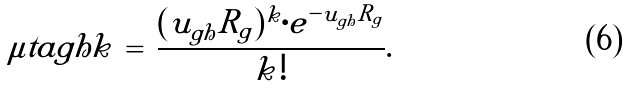<formula> <loc_0><loc_0><loc_500><loc_500>\mu t a { g } { h } { k } \, = \, \frac { ( u _ { g h } R _ { g } ) ^ { k } \cdot e ^ { - u _ { g h } R _ { g } } } { k ! } .</formula> 